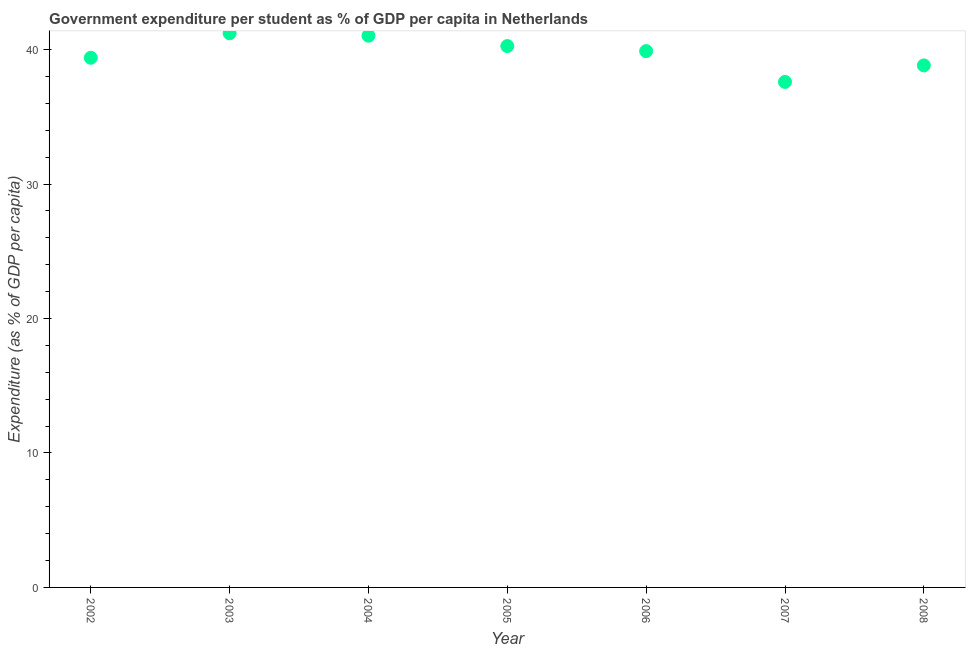What is the government expenditure per student in 2008?
Offer a very short reply. 38.82. Across all years, what is the maximum government expenditure per student?
Offer a terse response. 41.21. Across all years, what is the minimum government expenditure per student?
Your response must be concise. 37.6. In which year was the government expenditure per student maximum?
Offer a terse response. 2003. In which year was the government expenditure per student minimum?
Your response must be concise. 2007. What is the sum of the government expenditure per student?
Offer a terse response. 278.21. What is the difference between the government expenditure per student in 2003 and 2005?
Your answer should be compact. 0.95. What is the average government expenditure per student per year?
Give a very brief answer. 39.74. What is the median government expenditure per student?
Offer a terse response. 39.89. What is the ratio of the government expenditure per student in 2005 to that in 2006?
Provide a succinct answer. 1.01. Is the government expenditure per student in 2003 less than that in 2008?
Offer a very short reply. No. What is the difference between the highest and the second highest government expenditure per student?
Your response must be concise. 0.18. What is the difference between the highest and the lowest government expenditure per student?
Your answer should be very brief. 3.62. How many dotlines are there?
Ensure brevity in your answer.  1. What is the difference between two consecutive major ticks on the Y-axis?
Provide a short and direct response. 10. Does the graph contain any zero values?
Give a very brief answer. No. Does the graph contain grids?
Provide a succinct answer. No. What is the title of the graph?
Provide a short and direct response. Government expenditure per student as % of GDP per capita in Netherlands. What is the label or title of the Y-axis?
Give a very brief answer. Expenditure (as % of GDP per capita). What is the Expenditure (as % of GDP per capita) in 2002?
Ensure brevity in your answer.  39.39. What is the Expenditure (as % of GDP per capita) in 2003?
Give a very brief answer. 41.21. What is the Expenditure (as % of GDP per capita) in 2004?
Offer a terse response. 41.03. What is the Expenditure (as % of GDP per capita) in 2005?
Provide a short and direct response. 40.26. What is the Expenditure (as % of GDP per capita) in 2006?
Provide a short and direct response. 39.89. What is the Expenditure (as % of GDP per capita) in 2007?
Ensure brevity in your answer.  37.6. What is the Expenditure (as % of GDP per capita) in 2008?
Your answer should be very brief. 38.82. What is the difference between the Expenditure (as % of GDP per capita) in 2002 and 2003?
Keep it short and to the point. -1.82. What is the difference between the Expenditure (as % of GDP per capita) in 2002 and 2004?
Your answer should be very brief. -1.64. What is the difference between the Expenditure (as % of GDP per capita) in 2002 and 2005?
Your answer should be very brief. -0.87. What is the difference between the Expenditure (as % of GDP per capita) in 2002 and 2006?
Your answer should be very brief. -0.49. What is the difference between the Expenditure (as % of GDP per capita) in 2002 and 2007?
Provide a succinct answer. 1.8. What is the difference between the Expenditure (as % of GDP per capita) in 2002 and 2008?
Give a very brief answer. 0.57. What is the difference between the Expenditure (as % of GDP per capita) in 2003 and 2004?
Offer a very short reply. 0.18. What is the difference between the Expenditure (as % of GDP per capita) in 2003 and 2005?
Provide a succinct answer. 0.95. What is the difference between the Expenditure (as % of GDP per capita) in 2003 and 2006?
Your response must be concise. 1.33. What is the difference between the Expenditure (as % of GDP per capita) in 2003 and 2007?
Provide a short and direct response. 3.62. What is the difference between the Expenditure (as % of GDP per capita) in 2003 and 2008?
Keep it short and to the point. 2.39. What is the difference between the Expenditure (as % of GDP per capita) in 2004 and 2005?
Your answer should be very brief. 0.77. What is the difference between the Expenditure (as % of GDP per capita) in 2004 and 2006?
Offer a very short reply. 1.15. What is the difference between the Expenditure (as % of GDP per capita) in 2004 and 2007?
Your answer should be very brief. 3.44. What is the difference between the Expenditure (as % of GDP per capita) in 2004 and 2008?
Make the answer very short. 2.21. What is the difference between the Expenditure (as % of GDP per capita) in 2005 and 2006?
Provide a short and direct response. 0.38. What is the difference between the Expenditure (as % of GDP per capita) in 2005 and 2007?
Provide a succinct answer. 2.67. What is the difference between the Expenditure (as % of GDP per capita) in 2005 and 2008?
Provide a short and direct response. 1.44. What is the difference between the Expenditure (as % of GDP per capita) in 2006 and 2007?
Your answer should be very brief. 2.29. What is the difference between the Expenditure (as % of GDP per capita) in 2006 and 2008?
Your answer should be compact. 1.06. What is the difference between the Expenditure (as % of GDP per capita) in 2007 and 2008?
Offer a terse response. -1.23. What is the ratio of the Expenditure (as % of GDP per capita) in 2002 to that in 2003?
Your answer should be compact. 0.96. What is the ratio of the Expenditure (as % of GDP per capita) in 2002 to that in 2004?
Your answer should be very brief. 0.96. What is the ratio of the Expenditure (as % of GDP per capita) in 2002 to that in 2006?
Ensure brevity in your answer.  0.99. What is the ratio of the Expenditure (as % of GDP per capita) in 2002 to that in 2007?
Make the answer very short. 1.05. What is the ratio of the Expenditure (as % of GDP per capita) in 2003 to that in 2006?
Your answer should be very brief. 1.03. What is the ratio of the Expenditure (as % of GDP per capita) in 2003 to that in 2007?
Ensure brevity in your answer.  1.1. What is the ratio of the Expenditure (as % of GDP per capita) in 2003 to that in 2008?
Ensure brevity in your answer.  1.06. What is the ratio of the Expenditure (as % of GDP per capita) in 2004 to that in 2006?
Offer a very short reply. 1.03. What is the ratio of the Expenditure (as % of GDP per capita) in 2004 to that in 2007?
Provide a short and direct response. 1.09. What is the ratio of the Expenditure (as % of GDP per capita) in 2004 to that in 2008?
Provide a short and direct response. 1.06. What is the ratio of the Expenditure (as % of GDP per capita) in 2005 to that in 2006?
Offer a terse response. 1.01. What is the ratio of the Expenditure (as % of GDP per capita) in 2005 to that in 2007?
Give a very brief answer. 1.07. What is the ratio of the Expenditure (as % of GDP per capita) in 2006 to that in 2007?
Offer a very short reply. 1.06. What is the ratio of the Expenditure (as % of GDP per capita) in 2007 to that in 2008?
Provide a short and direct response. 0.97. 